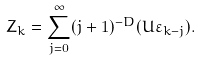Convert formula to latex. <formula><loc_0><loc_0><loc_500><loc_500>Z _ { k } = \sum _ { j = 0 } ^ { \infty } ( j + 1 ) ^ { - D } ( U \varepsilon _ { k - j } ) .</formula> 